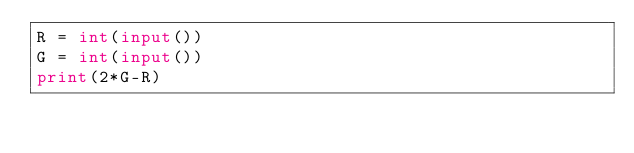Convert code to text. <code><loc_0><loc_0><loc_500><loc_500><_Python_>R = int(input())
G = int(input())
print(2*G-R)</code> 